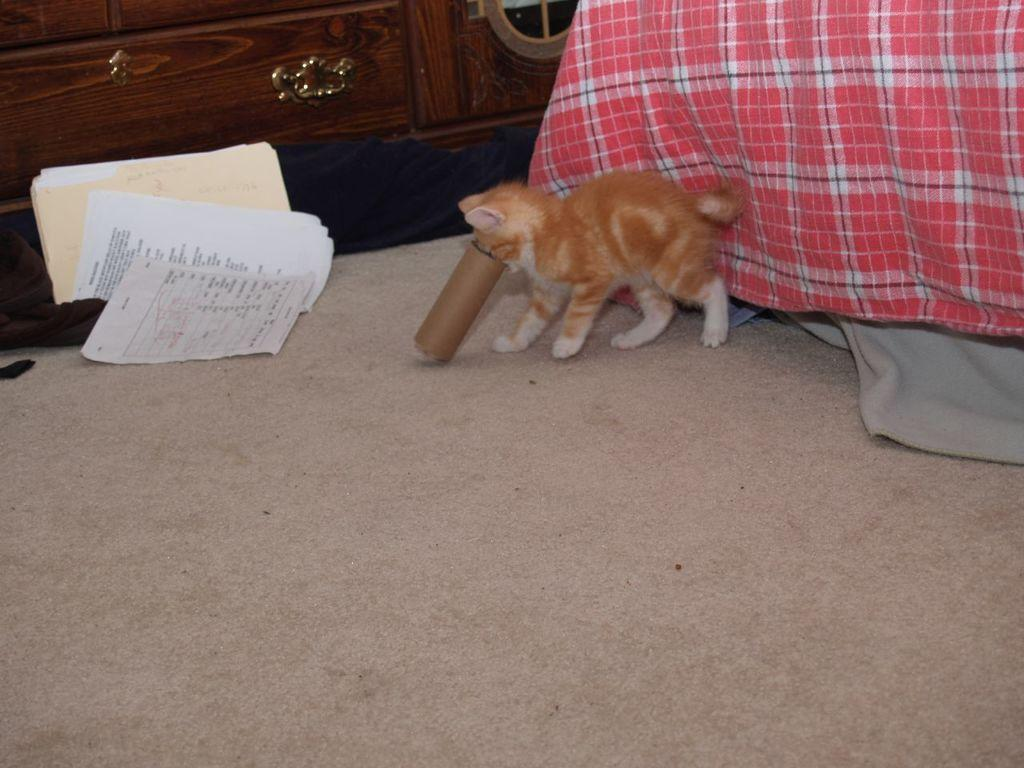What animal can be seen on the floor in the image? There is a cat on the floor in the image. What type of items are present in the image besides the cat? There are papers, clothes, a wooden object, and other objects in the image. Can you describe the wooden object in the image? Unfortunately, the facts provided do not give enough information to describe the wooden object in detail. How many objects can be seen in the image? There are at least five objects mentioned in the facts: a cat, papers, clothes, a wooden object, and other objects. How does the cat participate in the society depicted in the image? The image does not depict a society, and therefore it is not possible to determine how the cat participates in it. What type of rifle can be seen in the image? There is no rifle present in the image. 